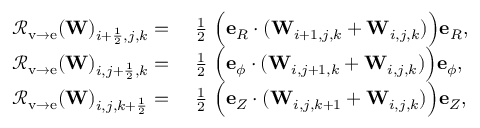Convert formula to latex. <formula><loc_0><loc_0><loc_500><loc_500>\begin{array} { r l } { { \mathcal { R } } _ { v \rightarrow e } ( W ) _ { i + \frac { 1 } { 2 } , j , k } = } & { \frac { 1 } { 2 } { \left ( } e _ { R } \cdot ( W _ { i + 1 , j , k } + W _ { i , j , k } ) { \right ) } e _ { R } , } \\ { { \mathcal { R } } _ { v \rightarrow e } ( W ) _ { i , j + \frac { 1 } { 2 } , k } = } & { \frac { 1 } { 2 } { \left ( } e _ { \phi } \cdot ( W _ { i , j + 1 , k } + W _ { i , j , k } ) { \right ) } e _ { \phi } , } \\ { { \mathcal { R } } _ { v \rightarrow e } ( W ) _ { i , j , k + \frac { 1 } { 2 } } = } & { \frac { 1 } { 2 } { \left ( } e _ { Z } \cdot ( W _ { i , j , k + 1 } + W _ { i , j , k } ) { \right ) } e _ { Z } , } \end{array}</formula> 